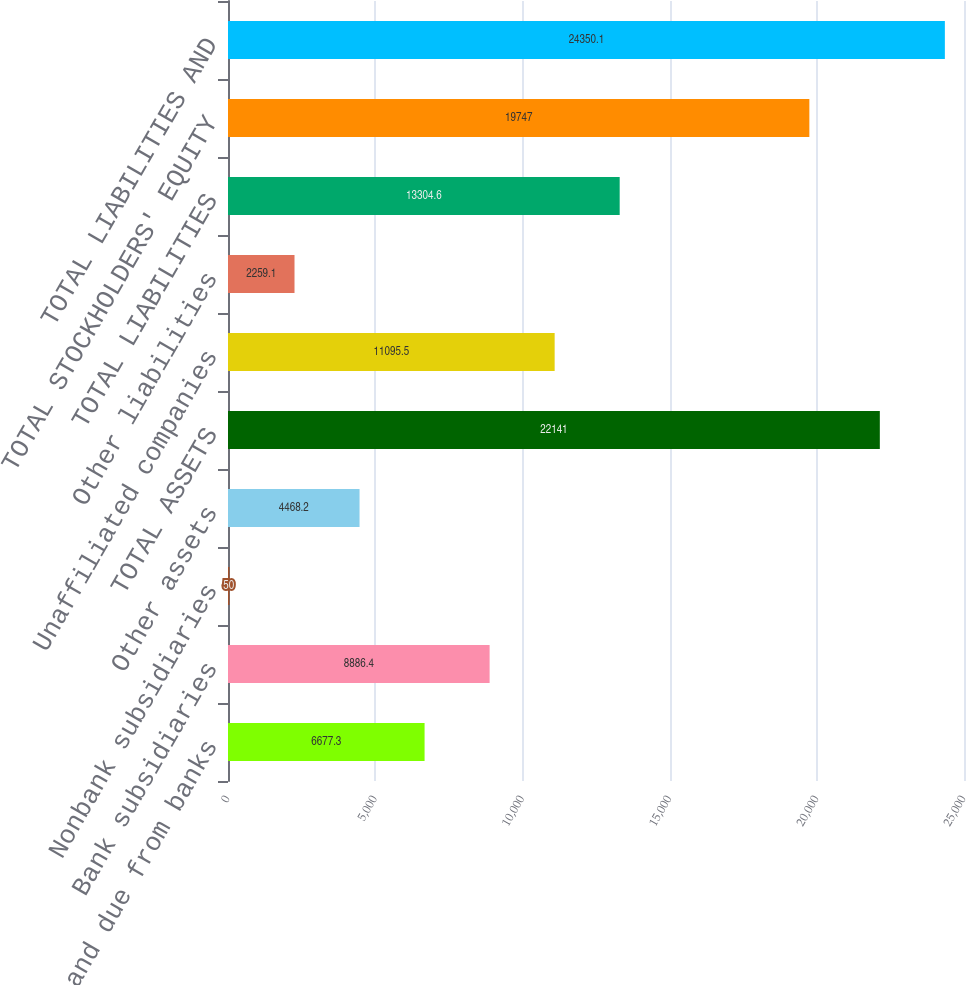Convert chart to OTSL. <chart><loc_0><loc_0><loc_500><loc_500><bar_chart><fcel>Cash and due from banks<fcel>Bank subsidiaries<fcel>Nonbank subsidiaries<fcel>Other assets<fcel>TOTAL ASSETS<fcel>Unaffiliated companies<fcel>Other liabilities<fcel>TOTAL LIABILITIES<fcel>TOTAL STOCKHOLDERS' EQUITY<fcel>TOTAL LIABILITIES AND<nl><fcel>6677.3<fcel>8886.4<fcel>50<fcel>4468.2<fcel>22141<fcel>11095.5<fcel>2259.1<fcel>13304.6<fcel>19747<fcel>24350.1<nl></chart> 